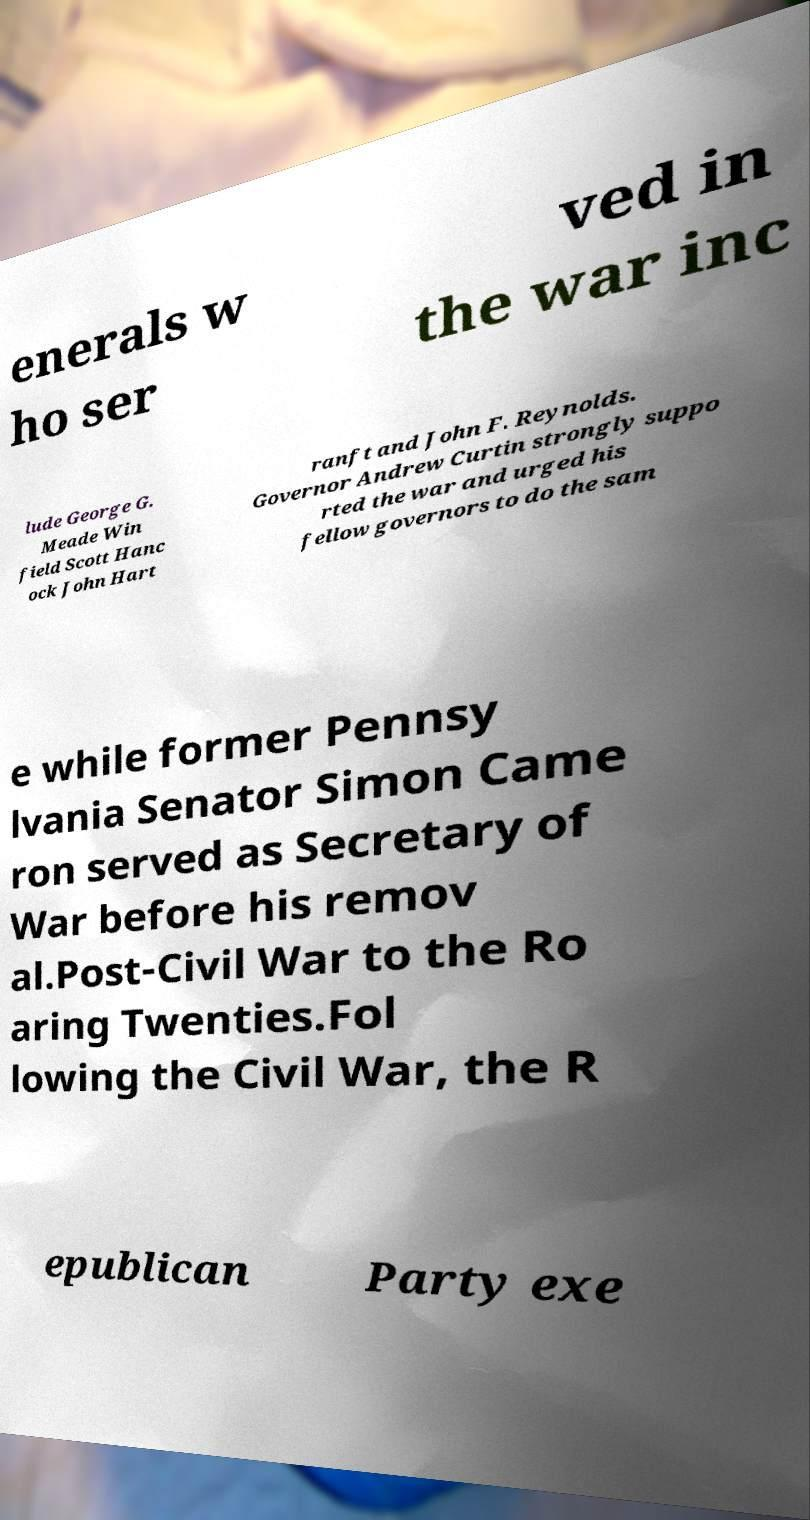Please read and relay the text visible in this image. What does it say? enerals w ho ser ved in the war inc lude George G. Meade Win field Scott Hanc ock John Hart ranft and John F. Reynolds. Governor Andrew Curtin strongly suppo rted the war and urged his fellow governors to do the sam e while former Pennsy lvania Senator Simon Came ron served as Secretary of War before his remov al.Post-Civil War to the Ro aring Twenties.Fol lowing the Civil War, the R epublican Party exe 